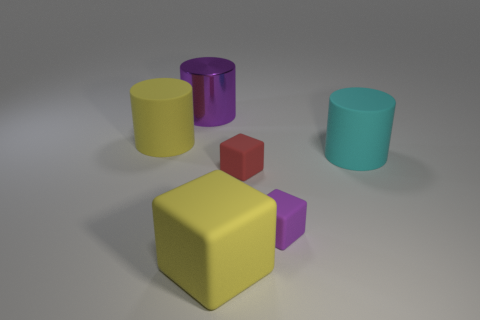Does the red rubber thing have the same size as the cyan thing? The red object appears to be a cube and is smaller in size compared to the cyan cylinder when considering their overall dimensions. 